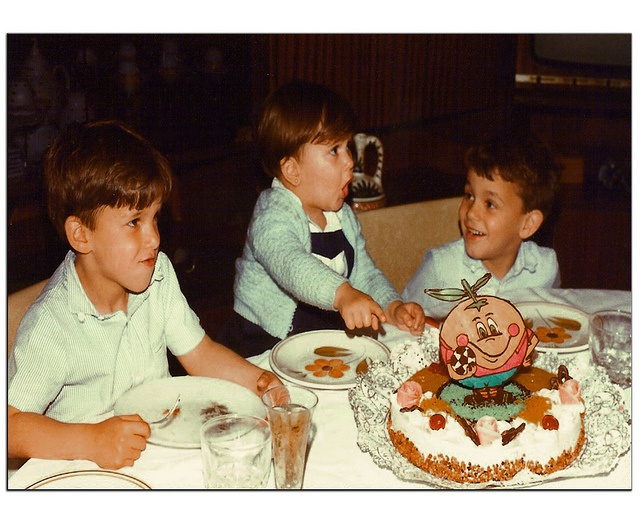Describe the objects in this image and their specific colors. I can see people in white, beige, tan, black, and lightyellow tones, people in white, black, darkgray, beige, and tan tones, cake in white, beige, tan, brown, and maroon tones, people in white, black, brown, darkgray, and beige tones, and dining table in white, beige, darkgray, and gray tones in this image. 